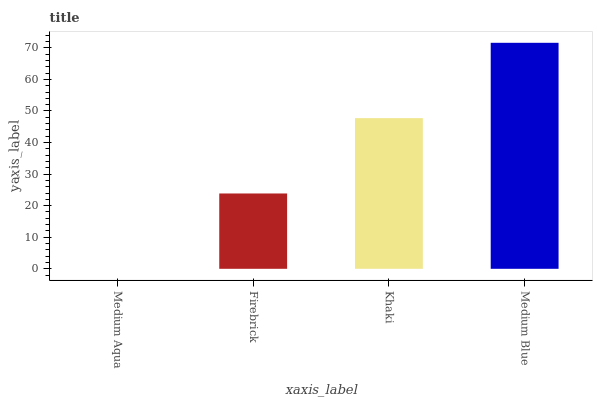Is Medium Aqua the minimum?
Answer yes or no. Yes. Is Medium Blue the maximum?
Answer yes or no. Yes. Is Firebrick the minimum?
Answer yes or no. No. Is Firebrick the maximum?
Answer yes or no. No. Is Firebrick greater than Medium Aqua?
Answer yes or no. Yes. Is Medium Aqua less than Firebrick?
Answer yes or no. Yes. Is Medium Aqua greater than Firebrick?
Answer yes or no. No. Is Firebrick less than Medium Aqua?
Answer yes or no. No. Is Khaki the high median?
Answer yes or no. Yes. Is Firebrick the low median?
Answer yes or no. Yes. Is Medium Blue the high median?
Answer yes or no. No. Is Medium Aqua the low median?
Answer yes or no. No. 